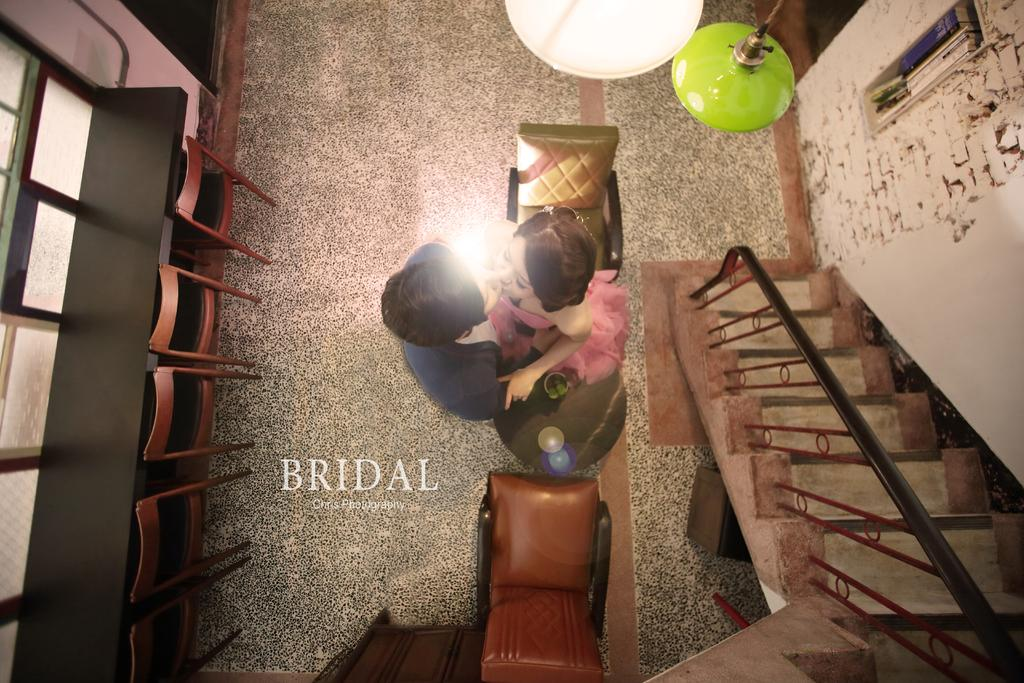Where was the image taken? The image was taken in a room. How many people are in the image? There are two persons standing in the room. What type of furniture is present in the room? There are chairs and a table on the floor. Is there any architectural feature in the room? Yes, there is a staircase in the room. What is the source of light in the image? There are lights on top of the persons, chairs, and table. What type of knowledge is being shared between the two persons in the image? There is no indication in the image of any knowledge being shared between the two persons. Can you tell me how many fathers are present in the image? There is no mention of a father or any familial relationship in the image. 